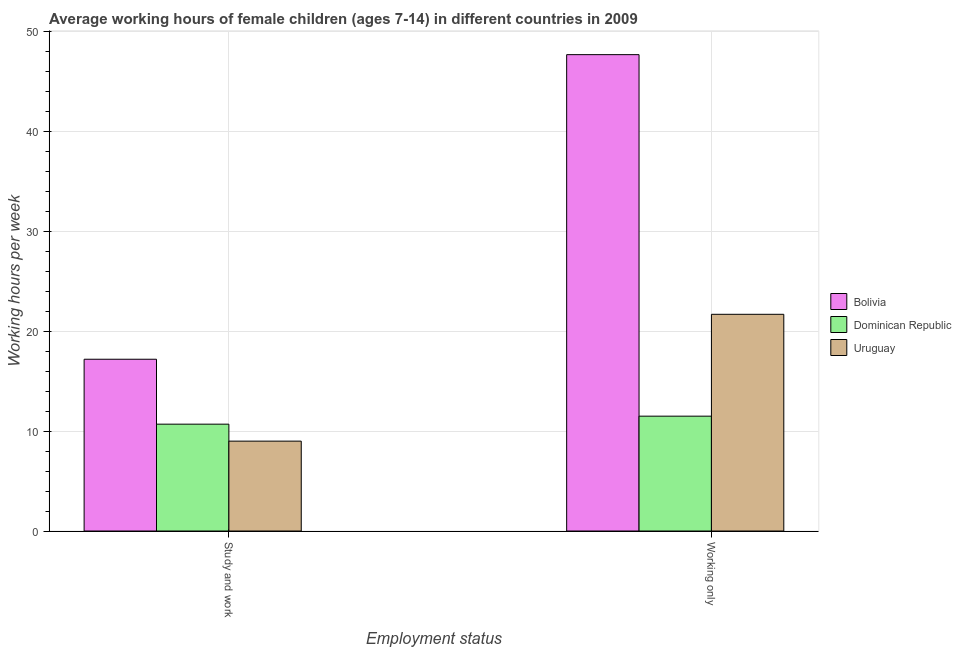How many different coloured bars are there?
Provide a short and direct response. 3. How many groups of bars are there?
Ensure brevity in your answer.  2. Are the number of bars per tick equal to the number of legend labels?
Ensure brevity in your answer.  Yes. How many bars are there on the 2nd tick from the left?
Provide a succinct answer. 3. How many bars are there on the 1st tick from the right?
Provide a succinct answer. 3. What is the label of the 2nd group of bars from the left?
Your answer should be very brief. Working only. In which country was the average working hour of children involved in only work minimum?
Keep it short and to the point. Dominican Republic. What is the total average working hour of children involved in study and work in the graph?
Your answer should be compact. 36.9. What is the difference between the average working hour of children involved in study and work in Dominican Republic and that in Uruguay?
Provide a succinct answer. 1.7. What is the difference between the average working hour of children involved in study and work in Dominican Republic and the average working hour of children involved in only work in Bolivia?
Keep it short and to the point. -37. What is the average average working hour of children involved in study and work per country?
Your answer should be very brief. 12.3. What is the difference between the average working hour of children involved in only work and average working hour of children involved in study and work in Bolivia?
Give a very brief answer. 30.5. What is the ratio of the average working hour of children involved in only work in Uruguay to that in Bolivia?
Make the answer very short. 0.45. In how many countries, is the average working hour of children involved in only work greater than the average average working hour of children involved in only work taken over all countries?
Your answer should be compact. 1. What does the 3rd bar from the left in Working only represents?
Offer a terse response. Uruguay. Are all the bars in the graph horizontal?
Your answer should be compact. No. How many countries are there in the graph?
Offer a very short reply. 3. What is the difference between two consecutive major ticks on the Y-axis?
Your answer should be very brief. 10. Are the values on the major ticks of Y-axis written in scientific E-notation?
Provide a succinct answer. No. Does the graph contain any zero values?
Provide a short and direct response. No. Does the graph contain grids?
Ensure brevity in your answer.  Yes. What is the title of the graph?
Your answer should be very brief. Average working hours of female children (ages 7-14) in different countries in 2009. What is the label or title of the X-axis?
Keep it short and to the point. Employment status. What is the label or title of the Y-axis?
Offer a terse response. Working hours per week. What is the Working hours per week in Bolivia in Study and work?
Provide a short and direct response. 17.2. What is the Working hours per week of Dominican Republic in Study and work?
Keep it short and to the point. 10.7. What is the Working hours per week of Bolivia in Working only?
Offer a very short reply. 47.7. What is the Working hours per week of Uruguay in Working only?
Offer a terse response. 21.7. Across all Employment status, what is the maximum Working hours per week of Bolivia?
Your answer should be very brief. 47.7. Across all Employment status, what is the maximum Working hours per week in Dominican Republic?
Offer a very short reply. 11.5. Across all Employment status, what is the maximum Working hours per week in Uruguay?
Your answer should be very brief. 21.7. Across all Employment status, what is the minimum Working hours per week in Uruguay?
Offer a terse response. 9. What is the total Working hours per week in Bolivia in the graph?
Your response must be concise. 64.9. What is the total Working hours per week in Dominican Republic in the graph?
Offer a terse response. 22.2. What is the total Working hours per week in Uruguay in the graph?
Your answer should be very brief. 30.7. What is the difference between the Working hours per week of Bolivia in Study and work and that in Working only?
Ensure brevity in your answer.  -30.5. What is the difference between the Working hours per week of Dominican Republic in Study and work and that in Working only?
Your response must be concise. -0.8. What is the difference between the Working hours per week in Uruguay in Study and work and that in Working only?
Keep it short and to the point. -12.7. What is the average Working hours per week in Bolivia per Employment status?
Keep it short and to the point. 32.45. What is the average Working hours per week of Dominican Republic per Employment status?
Offer a terse response. 11.1. What is the average Working hours per week of Uruguay per Employment status?
Give a very brief answer. 15.35. What is the difference between the Working hours per week of Bolivia and Working hours per week of Uruguay in Study and work?
Your response must be concise. 8.2. What is the difference between the Working hours per week of Bolivia and Working hours per week of Dominican Republic in Working only?
Make the answer very short. 36.2. What is the difference between the Working hours per week of Dominican Republic and Working hours per week of Uruguay in Working only?
Your answer should be very brief. -10.2. What is the ratio of the Working hours per week of Bolivia in Study and work to that in Working only?
Provide a succinct answer. 0.36. What is the ratio of the Working hours per week in Dominican Republic in Study and work to that in Working only?
Offer a very short reply. 0.93. What is the ratio of the Working hours per week in Uruguay in Study and work to that in Working only?
Your answer should be very brief. 0.41. What is the difference between the highest and the second highest Working hours per week of Bolivia?
Ensure brevity in your answer.  30.5. What is the difference between the highest and the lowest Working hours per week of Bolivia?
Make the answer very short. 30.5. What is the difference between the highest and the lowest Working hours per week in Dominican Republic?
Offer a terse response. 0.8. 